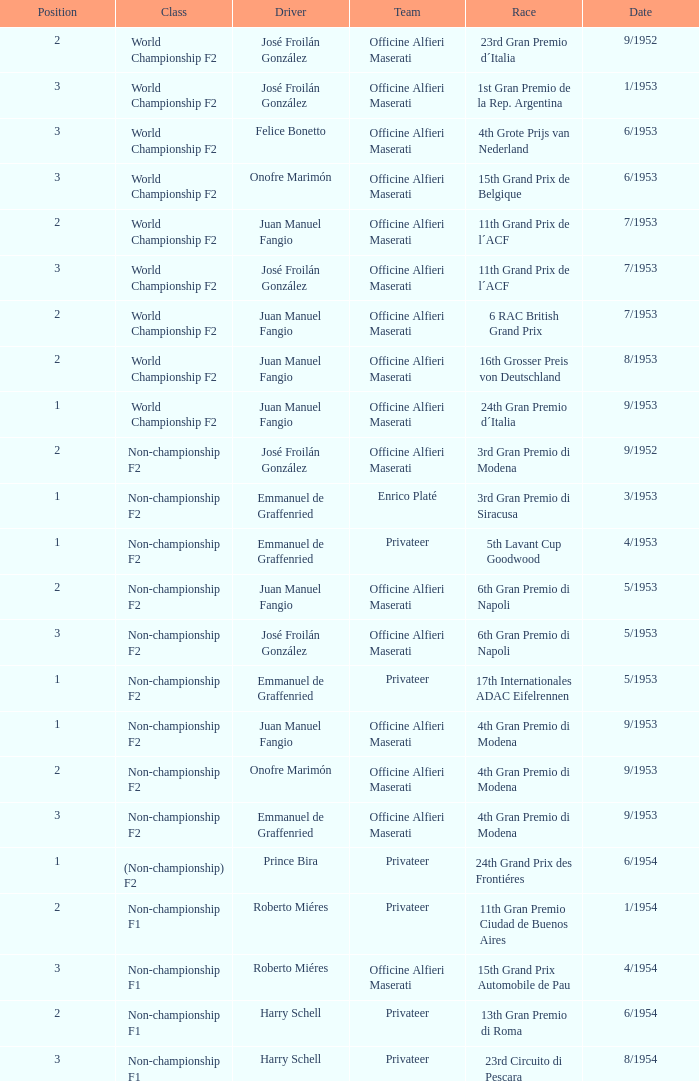What class has the date of 8/1954? Non-championship F1. 